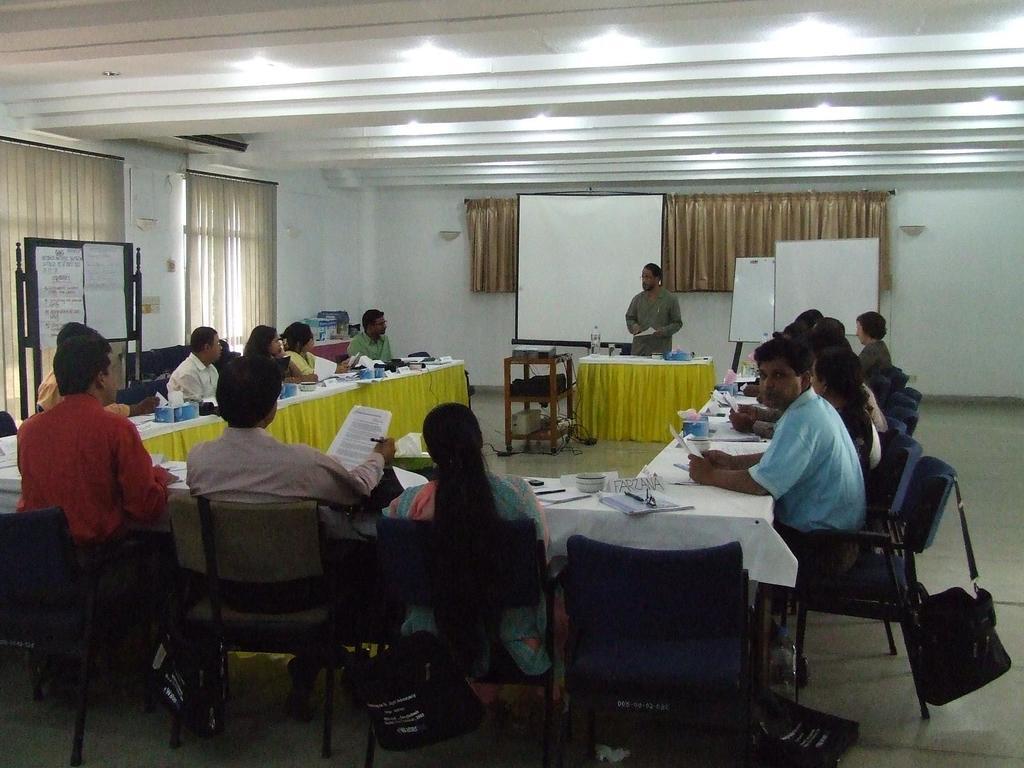Describe this image in one or two sentences. In the image we can see group of persons are sitting around the table. On table there is a book,pen,paper,tape and water bottle. In the center there is a man standing. In the background there is a wall,curtain,board,table and cloth. 